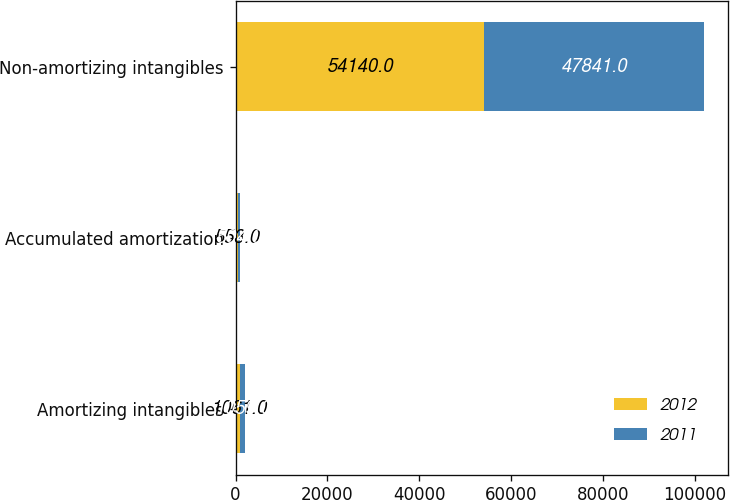Convert chart to OTSL. <chart><loc_0><loc_0><loc_500><loc_500><stacked_bar_chart><ecel><fcel>Amortizing intangibles<fcel>Accumulated amortization<fcel>Non-amortizing intangibles<nl><fcel>2012<fcel>1061<fcel>553<fcel>54140<nl><fcel>2011<fcel>1059<fcel>504<fcel>47841<nl></chart> 